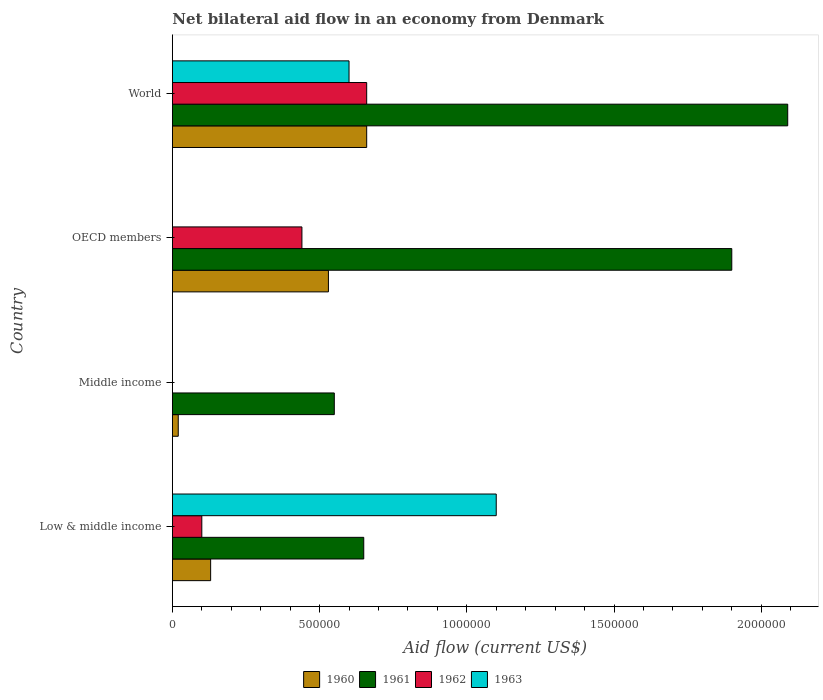How many groups of bars are there?
Ensure brevity in your answer.  4. Are the number of bars per tick equal to the number of legend labels?
Make the answer very short. No. Are the number of bars on each tick of the Y-axis equal?
Your response must be concise. No. How many bars are there on the 2nd tick from the top?
Ensure brevity in your answer.  3. How many bars are there on the 2nd tick from the bottom?
Provide a short and direct response. 2. In how many cases, is the number of bars for a given country not equal to the number of legend labels?
Provide a short and direct response. 2. Across all countries, what is the maximum net bilateral aid flow in 1962?
Give a very brief answer. 6.60e+05. In which country was the net bilateral aid flow in 1963 maximum?
Offer a very short reply. Low & middle income. What is the total net bilateral aid flow in 1962 in the graph?
Provide a short and direct response. 1.20e+06. What is the difference between the net bilateral aid flow in 1962 in Low & middle income and that in OECD members?
Your answer should be very brief. -3.40e+05. What is the difference between the net bilateral aid flow in 1963 in Middle income and the net bilateral aid flow in 1961 in Low & middle income?
Keep it short and to the point. -6.50e+05. What is the average net bilateral aid flow in 1960 per country?
Your answer should be compact. 3.35e+05. What is the difference between the net bilateral aid flow in 1960 and net bilateral aid flow in 1961 in OECD members?
Keep it short and to the point. -1.37e+06. What is the ratio of the net bilateral aid flow in 1960 in Low & middle income to that in World?
Your answer should be compact. 0.2. Is the difference between the net bilateral aid flow in 1960 in Low & middle income and OECD members greater than the difference between the net bilateral aid flow in 1961 in Low & middle income and OECD members?
Give a very brief answer. Yes. What is the difference between the highest and the second highest net bilateral aid flow in 1960?
Your answer should be compact. 1.30e+05. What is the difference between the highest and the lowest net bilateral aid flow in 1961?
Ensure brevity in your answer.  1.54e+06. Is it the case that in every country, the sum of the net bilateral aid flow in 1963 and net bilateral aid flow in 1962 is greater than the net bilateral aid flow in 1960?
Your answer should be compact. No. How many countries are there in the graph?
Give a very brief answer. 4. Are the values on the major ticks of X-axis written in scientific E-notation?
Offer a very short reply. No. Does the graph contain any zero values?
Make the answer very short. Yes. Where does the legend appear in the graph?
Offer a very short reply. Bottom center. How many legend labels are there?
Offer a terse response. 4. How are the legend labels stacked?
Ensure brevity in your answer.  Horizontal. What is the title of the graph?
Make the answer very short. Net bilateral aid flow in an economy from Denmark. What is the label or title of the X-axis?
Ensure brevity in your answer.  Aid flow (current US$). What is the Aid flow (current US$) in 1960 in Low & middle income?
Offer a very short reply. 1.30e+05. What is the Aid flow (current US$) of 1961 in Low & middle income?
Make the answer very short. 6.50e+05. What is the Aid flow (current US$) of 1962 in Low & middle income?
Provide a short and direct response. 1.00e+05. What is the Aid flow (current US$) of 1963 in Low & middle income?
Ensure brevity in your answer.  1.10e+06. What is the Aid flow (current US$) of 1960 in Middle income?
Give a very brief answer. 2.00e+04. What is the Aid flow (current US$) of 1960 in OECD members?
Your response must be concise. 5.30e+05. What is the Aid flow (current US$) of 1961 in OECD members?
Make the answer very short. 1.90e+06. What is the Aid flow (current US$) in 1961 in World?
Give a very brief answer. 2.09e+06. What is the Aid flow (current US$) of 1962 in World?
Provide a short and direct response. 6.60e+05. Across all countries, what is the maximum Aid flow (current US$) of 1960?
Make the answer very short. 6.60e+05. Across all countries, what is the maximum Aid flow (current US$) of 1961?
Keep it short and to the point. 2.09e+06. Across all countries, what is the maximum Aid flow (current US$) in 1962?
Give a very brief answer. 6.60e+05. Across all countries, what is the maximum Aid flow (current US$) in 1963?
Give a very brief answer. 1.10e+06. Across all countries, what is the minimum Aid flow (current US$) of 1961?
Your answer should be very brief. 5.50e+05. Across all countries, what is the minimum Aid flow (current US$) in 1962?
Provide a short and direct response. 0. What is the total Aid flow (current US$) of 1960 in the graph?
Give a very brief answer. 1.34e+06. What is the total Aid flow (current US$) of 1961 in the graph?
Your answer should be very brief. 5.19e+06. What is the total Aid flow (current US$) of 1962 in the graph?
Ensure brevity in your answer.  1.20e+06. What is the total Aid flow (current US$) of 1963 in the graph?
Offer a terse response. 1.70e+06. What is the difference between the Aid flow (current US$) of 1960 in Low & middle income and that in Middle income?
Offer a very short reply. 1.10e+05. What is the difference between the Aid flow (current US$) in 1960 in Low & middle income and that in OECD members?
Offer a very short reply. -4.00e+05. What is the difference between the Aid flow (current US$) in 1961 in Low & middle income and that in OECD members?
Make the answer very short. -1.25e+06. What is the difference between the Aid flow (current US$) in 1960 in Low & middle income and that in World?
Your response must be concise. -5.30e+05. What is the difference between the Aid flow (current US$) in 1961 in Low & middle income and that in World?
Offer a terse response. -1.44e+06. What is the difference between the Aid flow (current US$) in 1962 in Low & middle income and that in World?
Give a very brief answer. -5.60e+05. What is the difference between the Aid flow (current US$) in 1963 in Low & middle income and that in World?
Ensure brevity in your answer.  5.00e+05. What is the difference between the Aid flow (current US$) of 1960 in Middle income and that in OECD members?
Provide a short and direct response. -5.10e+05. What is the difference between the Aid flow (current US$) in 1961 in Middle income and that in OECD members?
Give a very brief answer. -1.35e+06. What is the difference between the Aid flow (current US$) in 1960 in Middle income and that in World?
Give a very brief answer. -6.40e+05. What is the difference between the Aid flow (current US$) in 1961 in Middle income and that in World?
Offer a terse response. -1.54e+06. What is the difference between the Aid flow (current US$) of 1960 in OECD members and that in World?
Offer a very short reply. -1.30e+05. What is the difference between the Aid flow (current US$) in 1961 in OECD members and that in World?
Offer a terse response. -1.90e+05. What is the difference between the Aid flow (current US$) of 1962 in OECD members and that in World?
Make the answer very short. -2.20e+05. What is the difference between the Aid flow (current US$) in 1960 in Low & middle income and the Aid flow (current US$) in 1961 in Middle income?
Offer a very short reply. -4.20e+05. What is the difference between the Aid flow (current US$) of 1960 in Low & middle income and the Aid flow (current US$) of 1961 in OECD members?
Offer a very short reply. -1.77e+06. What is the difference between the Aid flow (current US$) in 1960 in Low & middle income and the Aid flow (current US$) in 1962 in OECD members?
Offer a very short reply. -3.10e+05. What is the difference between the Aid flow (current US$) in 1960 in Low & middle income and the Aid flow (current US$) in 1961 in World?
Provide a succinct answer. -1.96e+06. What is the difference between the Aid flow (current US$) of 1960 in Low & middle income and the Aid flow (current US$) of 1962 in World?
Provide a short and direct response. -5.30e+05. What is the difference between the Aid flow (current US$) in 1960 in Low & middle income and the Aid flow (current US$) in 1963 in World?
Keep it short and to the point. -4.70e+05. What is the difference between the Aid flow (current US$) of 1961 in Low & middle income and the Aid flow (current US$) of 1962 in World?
Give a very brief answer. -10000. What is the difference between the Aid flow (current US$) of 1961 in Low & middle income and the Aid flow (current US$) of 1963 in World?
Give a very brief answer. 5.00e+04. What is the difference between the Aid flow (current US$) in 1962 in Low & middle income and the Aid flow (current US$) in 1963 in World?
Make the answer very short. -5.00e+05. What is the difference between the Aid flow (current US$) in 1960 in Middle income and the Aid flow (current US$) in 1961 in OECD members?
Your answer should be very brief. -1.88e+06. What is the difference between the Aid flow (current US$) of 1960 in Middle income and the Aid flow (current US$) of 1962 in OECD members?
Provide a succinct answer. -4.20e+05. What is the difference between the Aid flow (current US$) in 1961 in Middle income and the Aid flow (current US$) in 1962 in OECD members?
Your answer should be compact. 1.10e+05. What is the difference between the Aid flow (current US$) of 1960 in Middle income and the Aid flow (current US$) of 1961 in World?
Provide a short and direct response. -2.07e+06. What is the difference between the Aid flow (current US$) of 1960 in Middle income and the Aid flow (current US$) of 1962 in World?
Provide a short and direct response. -6.40e+05. What is the difference between the Aid flow (current US$) in 1960 in Middle income and the Aid flow (current US$) in 1963 in World?
Provide a short and direct response. -5.80e+05. What is the difference between the Aid flow (current US$) of 1961 in Middle income and the Aid flow (current US$) of 1962 in World?
Keep it short and to the point. -1.10e+05. What is the difference between the Aid flow (current US$) in 1961 in Middle income and the Aid flow (current US$) in 1963 in World?
Keep it short and to the point. -5.00e+04. What is the difference between the Aid flow (current US$) of 1960 in OECD members and the Aid flow (current US$) of 1961 in World?
Your answer should be very brief. -1.56e+06. What is the difference between the Aid flow (current US$) in 1960 in OECD members and the Aid flow (current US$) in 1962 in World?
Give a very brief answer. -1.30e+05. What is the difference between the Aid flow (current US$) in 1960 in OECD members and the Aid flow (current US$) in 1963 in World?
Your answer should be compact. -7.00e+04. What is the difference between the Aid flow (current US$) of 1961 in OECD members and the Aid flow (current US$) of 1962 in World?
Your answer should be compact. 1.24e+06. What is the difference between the Aid flow (current US$) of 1961 in OECD members and the Aid flow (current US$) of 1963 in World?
Keep it short and to the point. 1.30e+06. What is the average Aid flow (current US$) of 1960 per country?
Provide a succinct answer. 3.35e+05. What is the average Aid flow (current US$) of 1961 per country?
Your answer should be compact. 1.30e+06. What is the average Aid flow (current US$) in 1962 per country?
Provide a succinct answer. 3.00e+05. What is the average Aid flow (current US$) in 1963 per country?
Your answer should be compact. 4.25e+05. What is the difference between the Aid flow (current US$) in 1960 and Aid flow (current US$) in 1961 in Low & middle income?
Ensure brevity in your answer.  -5.20e+05. What is the difference between the Aid flow (current US$) of 1960 and Aid flow (current US$) of 1963 in Low & middle income?
Provide a succinct answer. -9.70e+05. What is the difference between the Aid flow (current US$) of 1961 and Aid flow (current US$) of 1963 in Low & middle income?
Your answer should be very brief. -4.50e+05. What is the difference between the Aid flow (current US$) in 1962 and Aid flow (current US$) in 1963 in Low & middle income?
Provide a succinct answer. -1.00e+06. What is the difference between the Aid flow (current US$) in 1960 and Aid flow (current US$) in 1961 in Middle income?
Offer a terse response. -5.30e+05. What is the difference between the Aid flow (current US$) of 1960 and Aid flow (current US$) of 1961 in OECD members?
Your answer should be very brief. -1.37e+06. What is the difference between the Aid flow (current US$) of 1961 and Aid flow (current US$) of 1962 in OECD members?
Your answer should be very brief. 1.46e+06. What is the difference between the Aid flow (current US$) in 1960 and Aid flow (current US$) in 1961 in World?
Your response must be concise. -1.43e+06. What is the difference between the Aid flow (current US$) in 1961 and Aid flow (current US$) in 1962 in World?
Your answer should be compact. 1.43e+06. What is the difference between the Aid flow (current US$) in 1961 and Aid flow (current US$) in 1963 in World?
Make the answer very short. 1.49e+06. What is the ratio of the Aid flow (current US$) in 1961 in Low & middle income to that in Middle income?
Provide a short and direct response. 1.18. What is the ratio of the Aid flow (current US$) in 1960 in Low & middle income to that in OECD members?
Your answer should be very brief. 0.25. What is the ratio of the Aid flow (current US$) of 1961 in Low & middle income to that in OECD members?
Offer a very short reply. 0.34. What is the ratio of the Aid flow (current US$) of 1962 in Low & middle income to that in OECD members?
Offer a terse response. 0.23. What is the ratio of the Aid flow (current US$) of 1960 in Low & middle income to that in World?
Your answer should be very brief. 0.2. What is the ratio of the Aid flow (current US$) of 1961 in Low & middle income to that in World?
Ensure brevity in your answer.  0.31. What is the ratio of the Aid flow (current US$) of 1962 in Low & middle income to that in World?
Ensure brevity in your answer.  0.15. What is the ratio of the Aid flow (current US$) in 1963 in Low & middle income to that in World?
Keep it short and to the point. 1.83. What is the ratio of the Aid flow (current US$) of 1960 in Middle income to that in OECD members?
Your answer should be very brief. 0.04. What is the ratio of the Aid flow (current US$) of 1961 in Middle income to that in OECD members?
Keep it short and to the point. 0.29. What is the ratio of the Aid flow (current US$) of 1960 in Middle income to that in World?
Your answer should be very brief. 0.03. What is the ratio of the Aid flow (current US$) of 1961 in Middle income to that in World?
Provide a succinct answer. 0.26. What is the ratio of the Aid flow (current US$) in 1960 in OECD members to that in World?
Offer a terse response. 0.8. What is the ratio of the Aid flow (current US$) in 1961 in OECD members to that in World?
Your response must be concise. 0.91. What is the difference between the highest and the second highest Aid flow (current US$) in 1960?
Make the answer very short. 1.30e+05. What is the difference between the highest and the second highest Aid flow (current US$) of 1961?
Keep it short and to the point. 1.90e+05. What is the difference between the highest and the lowest Aid flow (current US$) of 1960?
Make the answer very short. 6.40e+05. What is the difference between the highest and the lowest Aid flow (current US$) in 1961?
Provide a short and direct response. 1.54e+06. What is the difference between the highest and the lowest Aid flow (current US$) in 1962?
Offer a terse response. 6.60e+05. What is the difference between the highest and the lowest Aid flow (current US$) in 1963?
Give a very brief answer. 1.10e+06. 